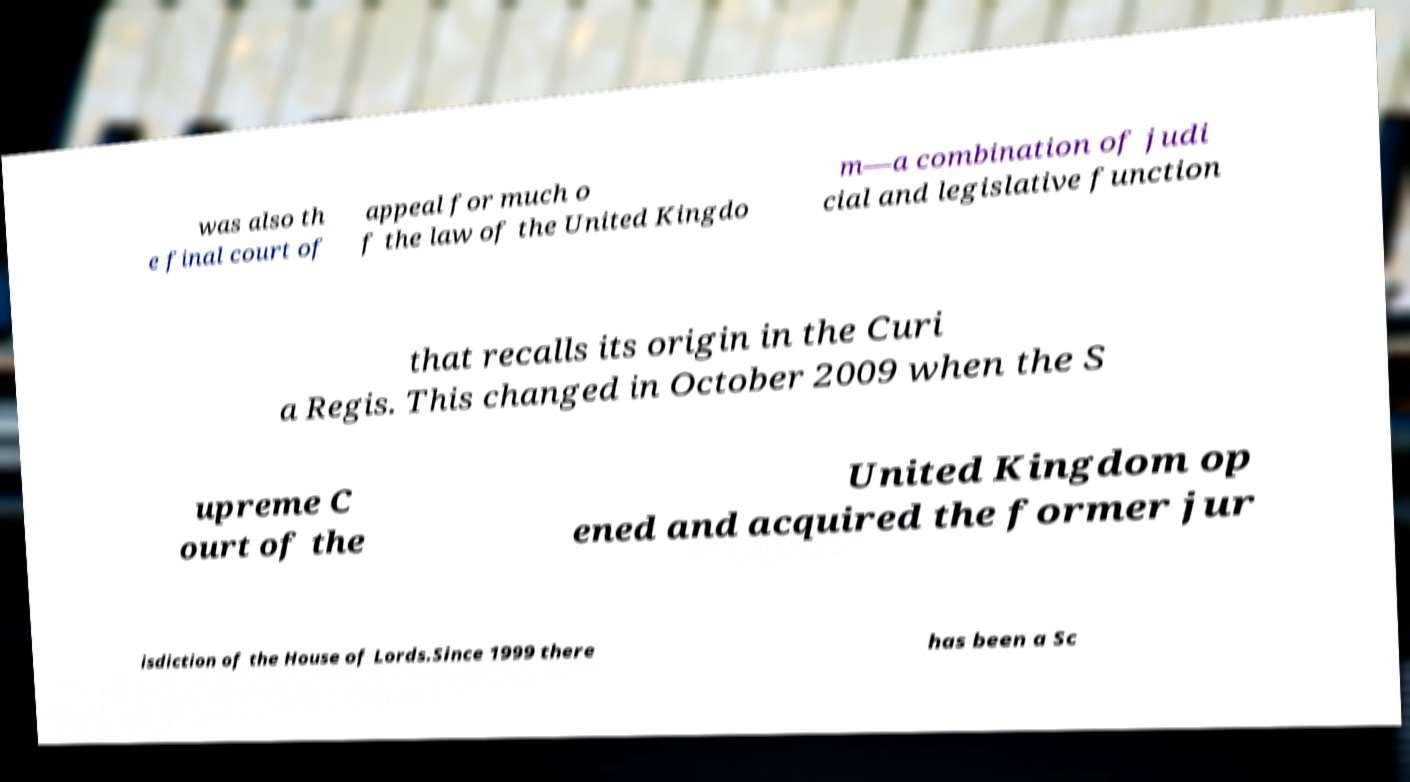What messages or text are displayed in this image? I need them in a readable, typed format. was also th e final court of appeal for much o f the law of the United Kingdo m—a combination of judi cial and legislative function that recalls its origin in the Curi a Regis. This changed in October 2009 when the S upreme C ourt of the United Kingdom op ened and acquired the former jur isdiction of the House of Lords.Since 1999 there has been a Sc 